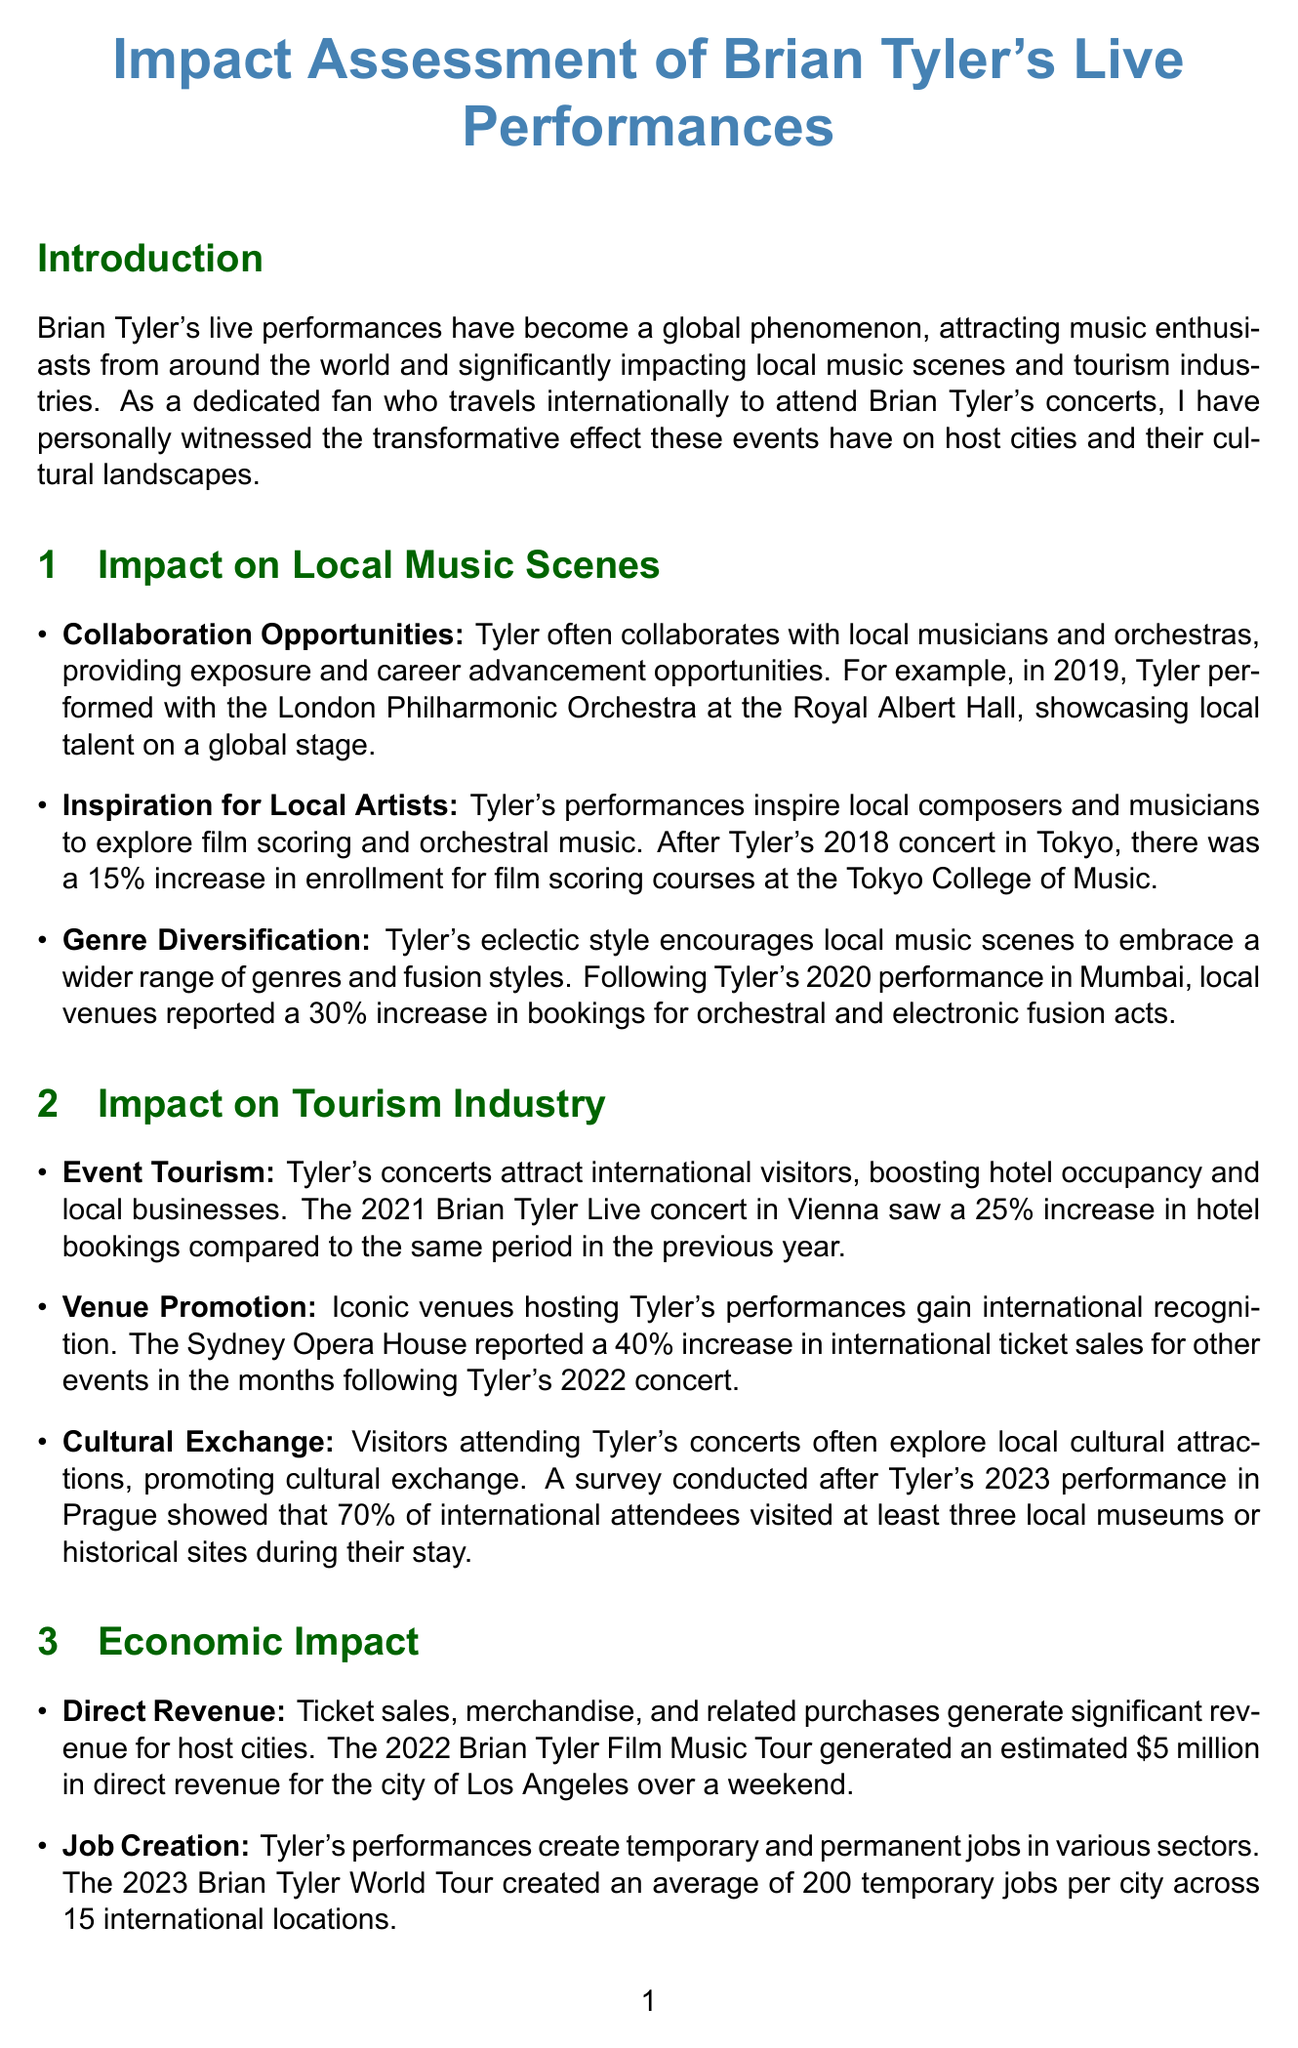what is the percentage increase in film scoring course enrollment after the Tokyo concert? The document states that there was a 15% increase in enrollment for film scoring courses at the Tokyo College of Music after Tyler's 2018 concert.
Answer: 15% which orchestra did Tyler perform with at the Royal Albert Hall? The document mentions that Tyler performed with the London Philharmonic Orchestra at the Royal Albert Hall in 2019.
Answer: London Philharmonic Orchestra what was the estimated direct revenue generated for Los Angeles during the 2022 Film Music Tour? The document indicates that the 2022 Brian Tyler Film Music Tour generated an estimated $5 million in direct revenue for the city of Los Angeles.
Answer: $5 million how much did hotel bookings increase during the 2021 concert in Vienna? According to the document, the 2021 Brian Tyler Live concert in Vienna saw a 25% increase in hotel bookings compared to the same period in the previous year.
Answer: 25% what improvement did the Mercedes-Benz Arena undergo in 2023? The document specifies that Shanghai's Mercedes-Benz Arena underwent a $10 million acoustic upgrade in 2023, motivated by Tyler's concert success.
Answer: $10 million acoustic upgrade which city saw a 40% increase in international ticket sales after Tyler's concert? The document states that the Sydney Opera House reported a 40% increase in international ticket sales for other events after Tyler's 2022 concert.
Answer: Sydney Opera House what percentage of international attendees visited local museums after the Prague concert? A survey conducted after Tyler's 2023 performance in Prague showed that 70% of international attendees visited at least three local museums or historical sites.
Answer: 70% what is one challenge mentioned regarding large-scale concerts? The document outlines several challenges, one being the significant environmental impacts of large-scale concerts.
Answer: Environmental impact how many temporary jobs did the 2023 World Tour create on average per city? The document mentions that the 2023 Brian Tyler World Tour created an average of 200 temporary jobs per city across 15 international locations.
Answer: 200 in what year did Tyler's concert in Melbourne lead to a budget increase for music programs? The document indicates that following Tyler's 2020 benefit concert in Melbourne, the city council approved a $2 million budget increase for public school music programs.
Answer: 2020 